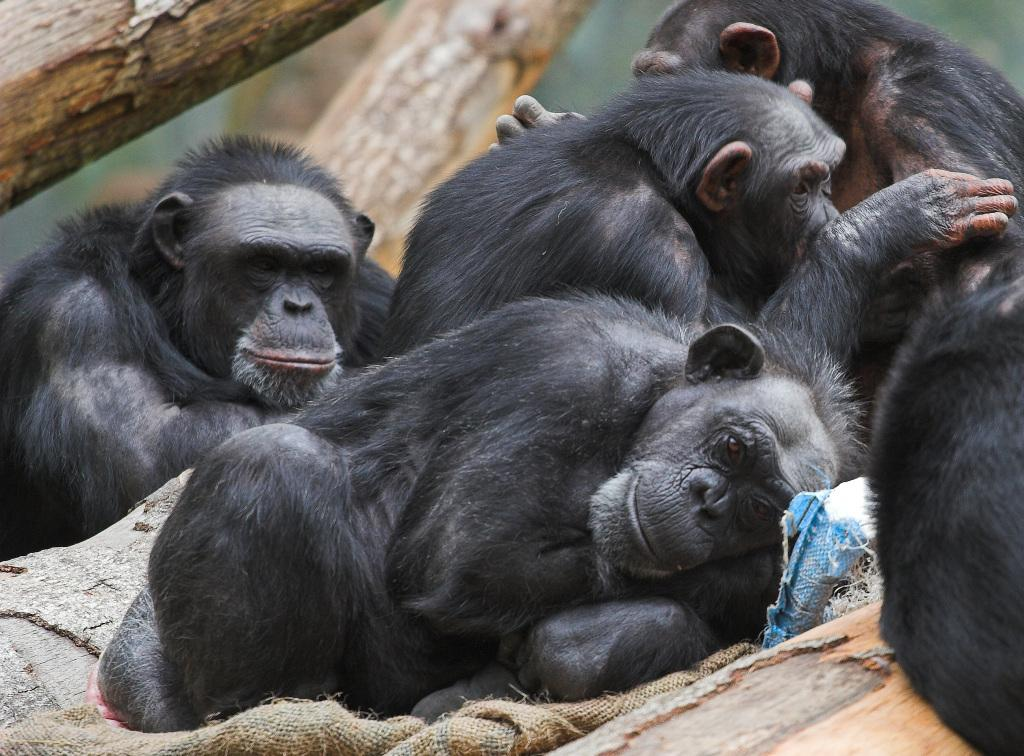What type of animals are in the image? There are chimpanzees in the image. What are the chimpanzees doing in the image? The chimpanzees are sitting and lying on a rock. What can be seen in the background of the image? There are tree logs visible in the background of the image. What type of liquid is being used by the chimpanzees in the image? There is no liquid present in the image; the chimpanzees are sitting and lying on a rock. What color is the paint on the chimpanzees in the image? There is no paint on the chimpanzees in the image; they are simply sitting and lying on a rock. 